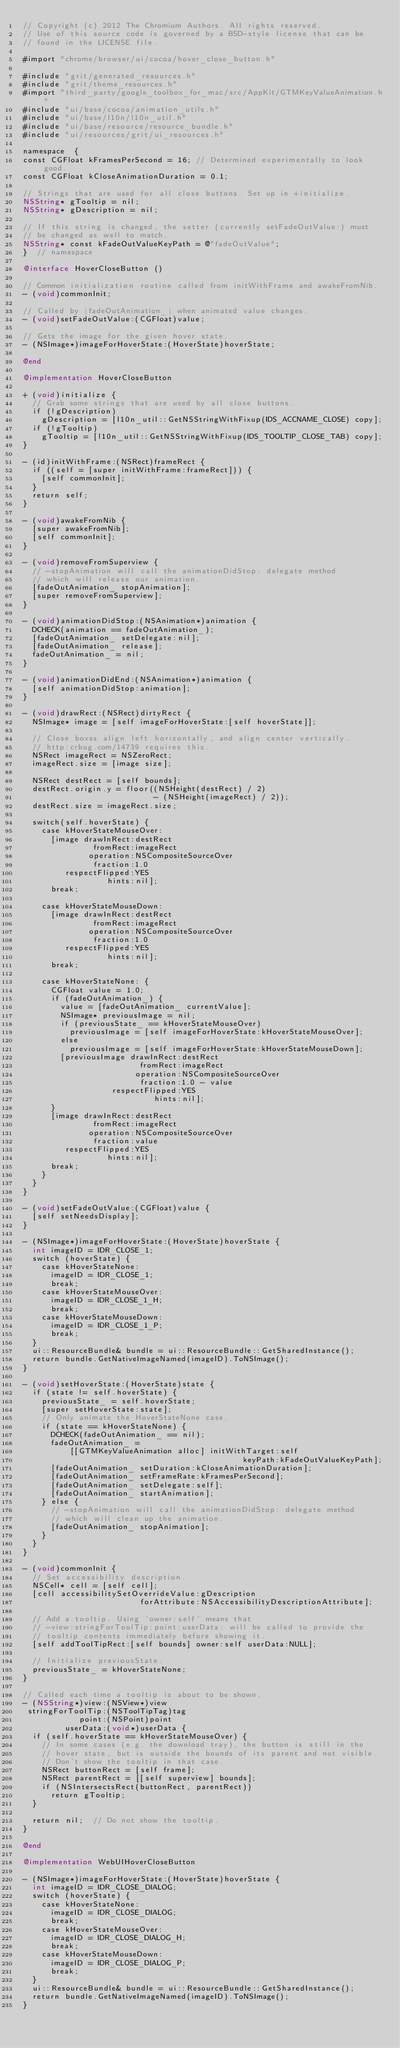Convert code to text. <code><loc_0><loc_0><loc_500><loc_500><_ObjectiveC_>// Copyright (c) 2012 The Chromium Authors. All rights reserved.
// Use of this source code is governed by a BSD-style license that can be
// found in the LICENSE file.

#import "chrome/browser/ui/cocoa/hover_close_button.h"

#include "grit/generated_resources.h"
#include "grit/theme_resources.h"
#import "third_party/google_toolbox_for_mac/src/AppKit/GTMKeyValueAnimation.h"
#include "ui/base/cocoa/animation_utils.h"
#include "ui/base/l10n/l10n_util.h"
#include "ui/base/resource/resource_bundle.h"
#include "ui/resources/grit/ui_resources.h"

namespace  {
const CGFloat kFramesPerSecond = 16; // Determined experimentally to look good.
const CGFloat kCloseAnimationDuration = 0.1;

// Strings that are used for all close buttons. Set up in +initialize.
NSString* gTooltip = nil;
NSString* gDescription = nil;

// If this string is changed, the setter (currently setFadeOutValue:) must
// be changed as well to match.
NSString* const kFadeOutValueKeyPath = @"fadeOutValue";
}  // namespace

@interface HoverCloseButton ()

// Common initialization routine called from initWithFrame and awakeFromNib.
- (void)commonInit;

// Called by |fadeOutAnimation_| when animated value changes.
- (void)setFadeOutValue:(CGFloat)value;

// Gets the image for the given hover state.
- (NSImage*)imageForHoverState:(HoverState)hoverState;

@end

@implementation HoverCloseButton

+ (void)initialize {
  // Grab some strings that are used by all close buttons.
  if (!gDescription)
    gDescription = [l10n_util::GetNSStringWithFixup(IDS_ACCNAME_CLOSE) copy];
  if (!gTooltip)
    gTooltip = [l10n_util::GetNSStringWithFixup(IDS_TOOLTIP_CLOSE_TAB) copy];
}

- (id)initWithFrame:(NSRect)frameRect {
  if ((self = [super initWithFrame:frameRect])) {
    [self commonInit];
  }
  return self;
}

- (void)awakeFromNib {
  [super awakeFromNib];
  [self commonInit];
}

- (void)removeFromSuperview {
  // -stopAnimation will call the animationDidStop: delegate method
  // which will release our animation.
  [fadeOutAnimation_ stopAnimation];
  [super removeFromSuperview];
}

- (void)animationDidStop:(NSAnimation*)animation {
  DCHECK(animation == fadeOutAnimation_);
  [fadeOutAnimation_ setDelegate:nil];
  [fadeOutAnimation_ release];
  fadeOutAnimation_ = nil;
}

- (void)animationDidEnd:(NSAnimation*)animation {
  [self animationDidStop:animation];
}

- (void)drawRect:(NSRect)dirtyRect {
  NSImage* image = [self imageForHoverState:[self hoverState]];

  // Close boxes align left horizontally, and align center vertically.
  // http:crbug.com/14739 requires this.
  NSRect imageRect = NSZeroRect;
  imageRect.size = [image size];

  NSRect destRect = [self bounds];
  destRect.origin.y = floor((NSHeight(destRect) / 2)
                            - (NSHeight(imageRect) / 2));
  destRect.size = imageRect.size;

  switch(self.hoverState) {
    case kHoverStateMouseOver:
      [image drawInRect:destRect
               fromRect:imageRect
              operation:NSCompositeSourceOver
               fraction:1.0
         respectFlipped:YES
                  hints:nil];
      break;

    case kHoverStateMouseDown:
      [image drawInRect:destRect
               fromRect:imageRect
              operation:NSCompositeSourceOver
               fraction:1.0
         respectFlipped:YES
                  hints:nil];
      break;

    case kHoverStateNone: {
      CGFloat value = 1.0;
      if (fadeOutAnimation_) {
        value = [fadeOutAnimation_ currentValue];
        NSImage* previousImage = nil;
        if (previousState_ == kHoverStateMouseOver)
          previousImage = [self imageForHoverState:kHoverStateMouseOver];
        else
          previousImage = [self imageForHoverState:kHoverStateMouseDown];
        [previousImage drawInRect:destRect
                         fromRect:imageRect
                        operation:NSCompositeSourceOver
                         fraction:1.0 - value
                   respectFlipped:YES
                            hints:nil];
      }
      [image drawInRect:destRect
               fromRect:imageRect
              operation:NSCompositeSourceOver
               fraction:value
         respectFlipped:YES
                  hints:nil];
      break;
    }
  }
}

- (void)setFadeOutValue:(CGFloat)value {
  [self setNeedsDisplay];
}

- (NSImage*)imageForHoverState:(HoverState)hoverState {
  int imageID = IDR_CLOSE_1;
  switch (hoverState) {
    case kHoverStateNone:
      imageID = IDR_CLOSE_1;
      break;
    case kHoverStateMouseOver:
      imageID = IDR_CLOSE_1_H;
      break;
    case kHoverStateMouseDown:
      imageID = IDR_CLOSE_1_P;
      break;
  }
  ui::ResourceBundle& bundle = ui::ResourceBundle::GetSharedInstance();
  return bundle.GetNativeImageNamed(imageID).ToNSImage();
}

- (void)setHoverState:(HoverState)state {
  if (state != self.hoverState) {
    previousState_ = self.hoverState;
    [super setHoverState:state];
    // Only animate the HoverStateNone case.
    if (state == kHoverStateNone) {
      DCHECK(fadeOutAnimation_ == nil);
      fadeOutAnimation_ =
          [[GTMKeyValueAnimation alloc] initWithTarget:self
                                               keyPath:kFadeOutValueKeyPath];
      [fadeOutAnimation_ setDuration:kCloseAnimationDuration];
      [fadeOutAnimation_ setFrameRate:kFramesPerSecond];
      [fadeOutAnimation_ setDelegate:self];
      [fadeOutAnimation_ startAnimation];
    } else {
      // -stopAnimation will call the animationDidStop: delegate method
      // which will clean up the animation.
      [fadeOutAnimation_ stopAnimation];
    }
  }
}

- (void)commonInit {
  // Set accessibility description.
  NSCell* cell = [self cell];
  [cell accessibilitySetOverrideValue:gDescription
                         forAttribute:NSAccessibilityDescriptionAttribute];

  // Add a tooltip. Using 'owner:self' means that
  // -view:stringForToolTip:point:userData: will be called to provide the
  // tooltip contents immediately before showing it.
  [self addToolTipRect:[self bounds] owner:self userData:NULL];

  // Initialize previousState.
  previousState_ = kHoverStateNone;
}

// Called each time a tooltip is about to be shown.
- (NSString*)view:(NSView*)view
 stringForToolTip:(NSToolTipTag)tag
            point:(NSPoint)point
         userData:(void*)userData {
  if (self.hoverState == kHoverStateMouseOver) {
    // In some cases (e.g. the download tray), the button is still in the
    // hover state, but is outside the bounds of its parent and not visible.
    // Don't show the tooltip in that case.
    NSRect buttonRect = [self frame];
    NSRect parentRect = [[self superview] bounds];
    if (NSIntersectsRect(buttonRect, parentRect))
      return gTooltip;
  }

  return nil;  // Do not show the tooltip.
}

@end

@implementation WebUIHoverCloseButton

- (NSImage*)imageForHoverState:(HoverState)hoverState {
  int imageID = IDR_CLOSE_DIALOG;
  switch (hoverState) {
    case kHoverStateNone:
      imageID = IDR_CLOSE_DIALOG;
      break;
    case kHoverStateMouseOver:
      imageID = IDR_CLOSE_DIALOG_H;
      break;
    case kHoverStateMouseDown:
      imageID = IDR_CLOSE_DIALOG_P;
      break;
  }
  ui::ResourceBundle& bundle = ui::ResourceBundle::GetSharedInstance();
  return bundle.GetNativeImageNamed(imageID).ToNSImage();
}
</code> 